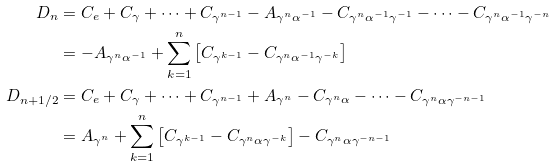<formula> <loc_0><loc_0><loc_500><loc_500>D _ { n } & = C _ { e } + C _ { \gamma } + \dots + C _ { \gamma ^ { n - 1 } } - A _ { \gamma ^ { n } \alpha ^ { - 1 } } - C _ { \gamma ^ { n } \alpha ^ { - 1 } \gamma ^ { - 1 } } - \dots - C _ { \gamma ^ { n } \alpha ^ { - 1 } \gamma ^ { - n } } \\ & = - A _ { \gamma ^ { n } \alpha ^ { - 1 } } + \sum _ { k = 1 } ^ { n } \left [ C _ { \gamma ^ { k - 1 } } - C _ { \gamma ^ { n } \alpha ^ { - 1 } \gamma ^ { - k } } \right ] \\ D _ { n + 1 / 2 } & = C _ { e } + C _ { \gamma } + \dots + C _ { \gamma ^ { n - 1 } } + A _ { \gamma ^ { n } } - C _ { \gamma ^ { n } \alpha } - \dots - C _ { \gamma ^ { n } \alpha \gamma ^ { - n - 1 } } \\ & = A _ { \gamma ^ { n } } + \sum _ { k = 1 } ^ { n } \left [ C _ { \gamma ^ { k - 1 } } - C _ { \gamma ^ { n } \alpha \gamma ^ { - k } } \right ] - C _ { \gamma ^ { n } \alpha \gamma ^ { - n - 1 } }</formula> 